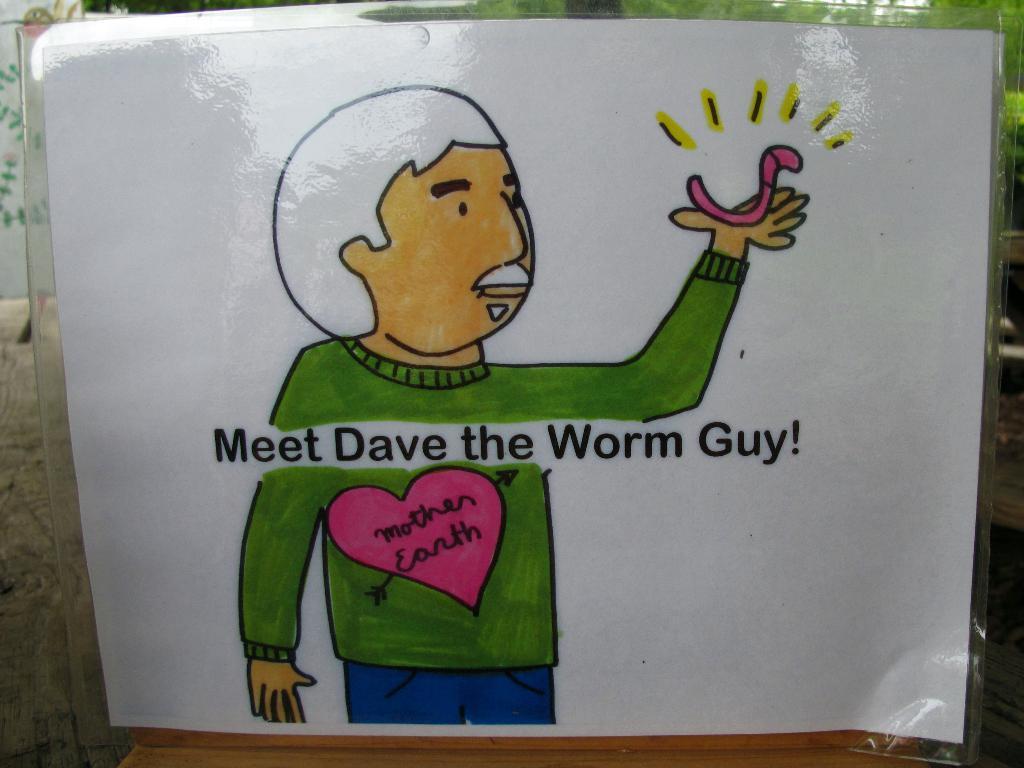Describe this image in one or two sentences. In this image there is a sketch of a person with some text written on it. 